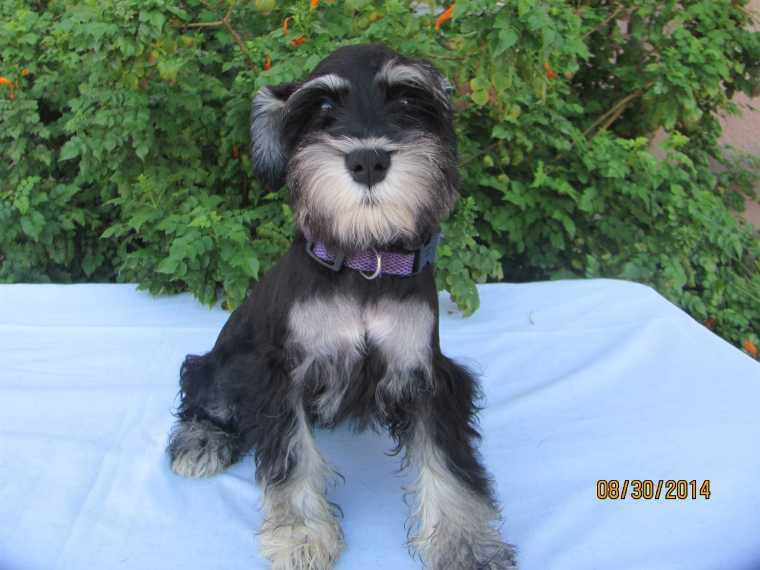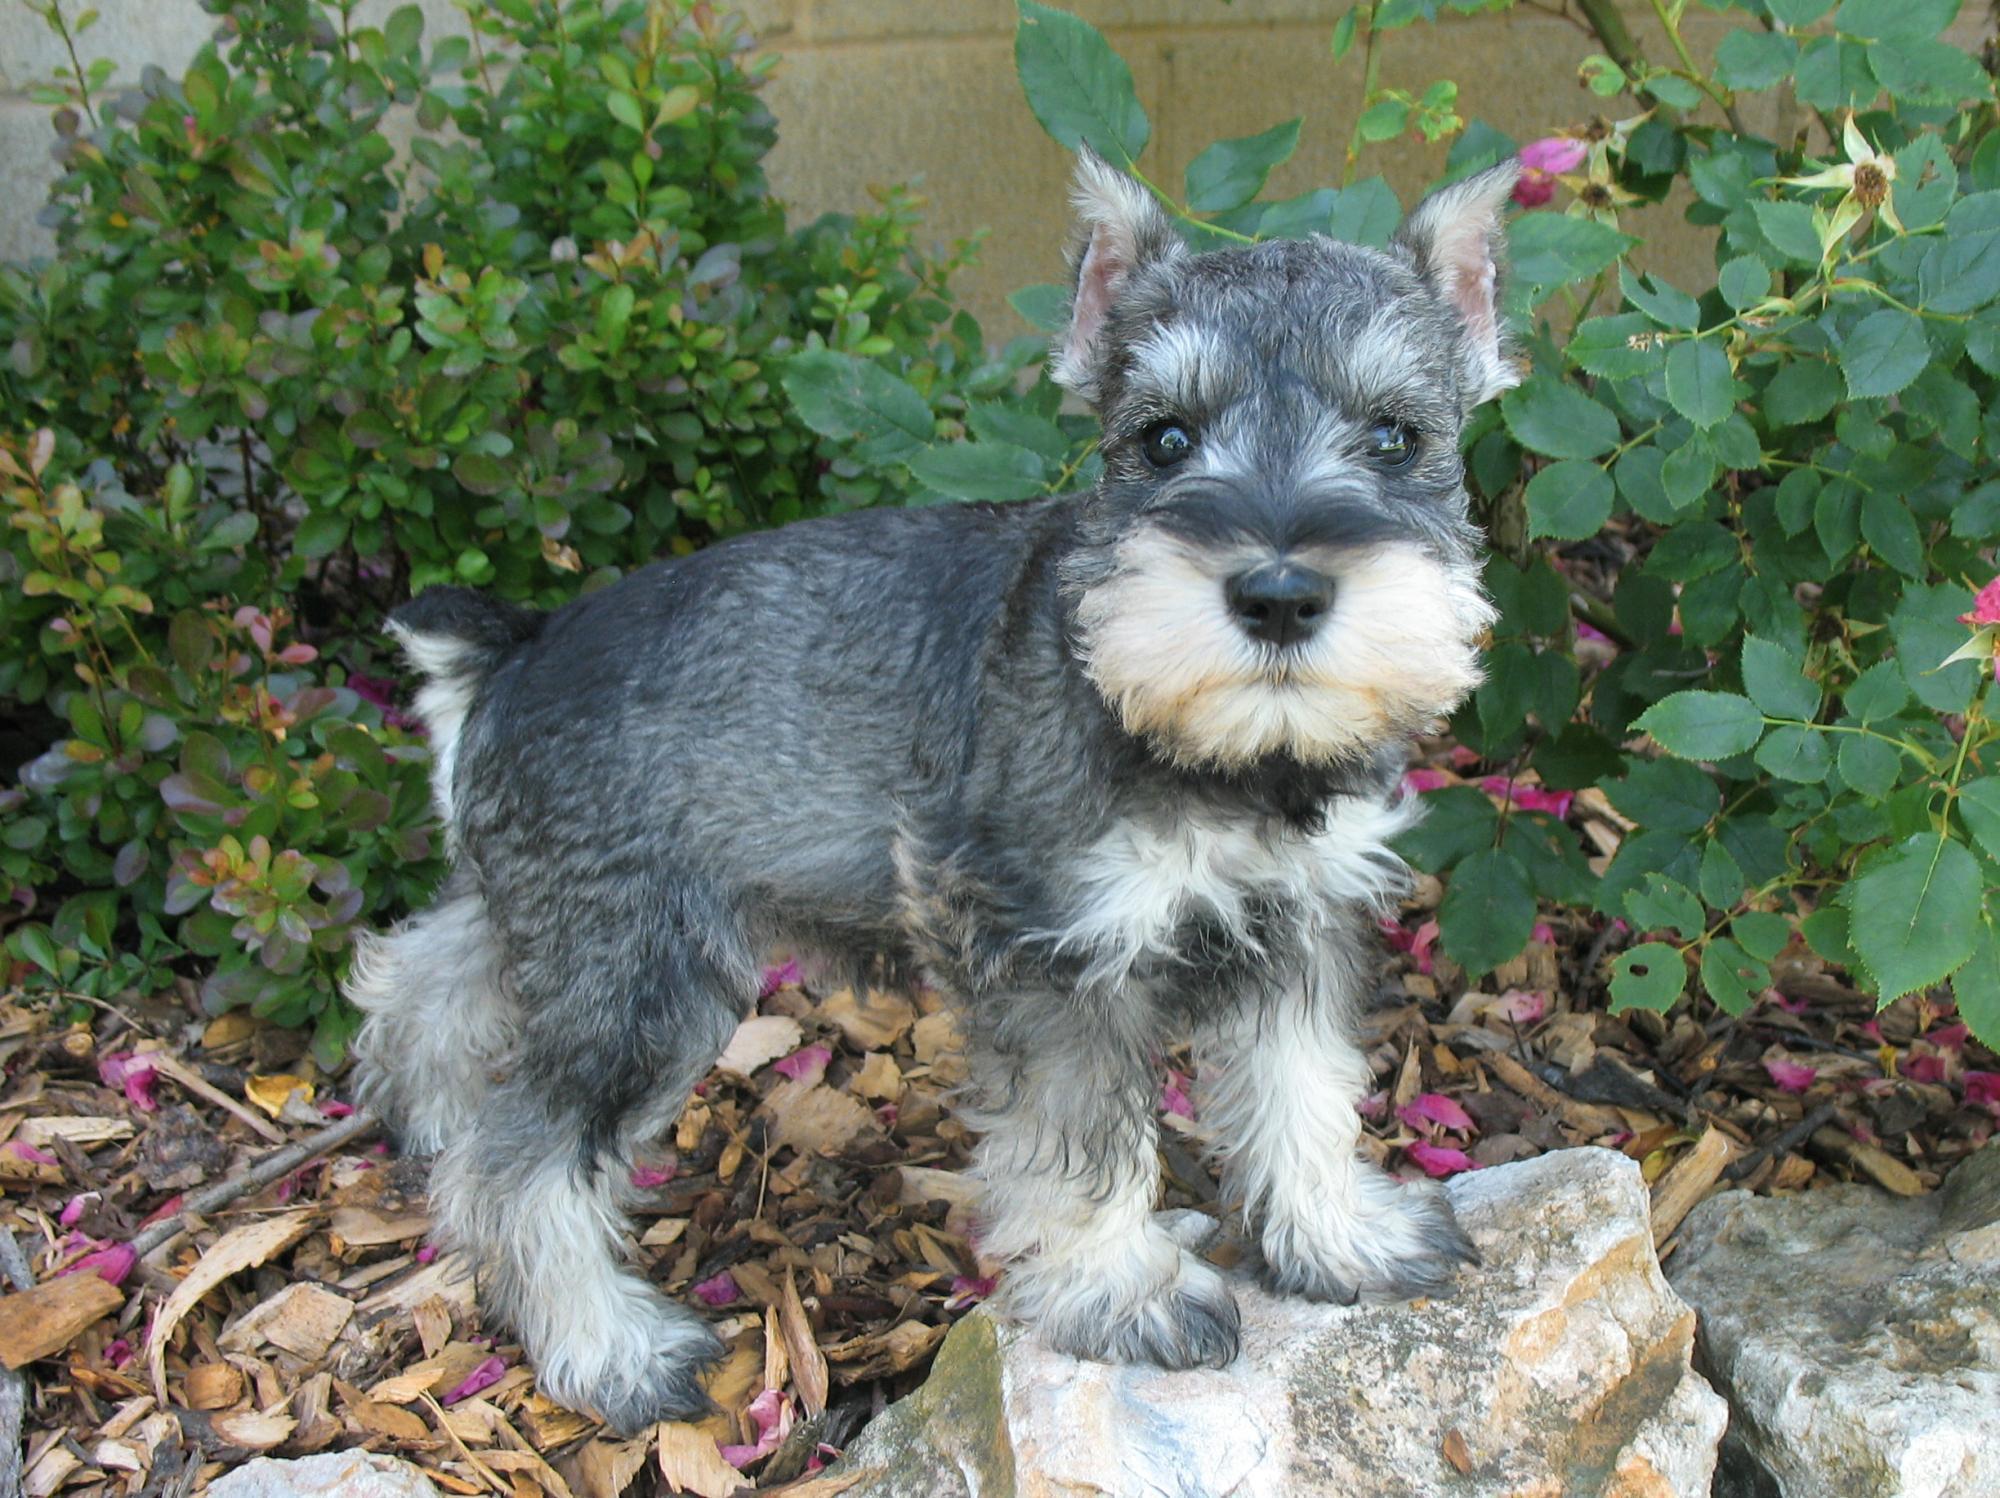The first image is the image on the left, the second image is the image on the right. For the images shown, is this caption "There are three dogs" true? Answer yes or no. No. The first image is the image on the left, the second image is the image on the right. Assess this claim about the two images: "Two schnauzers pose in the grass in one image.". Correct or not? Answer yes or no. No. 